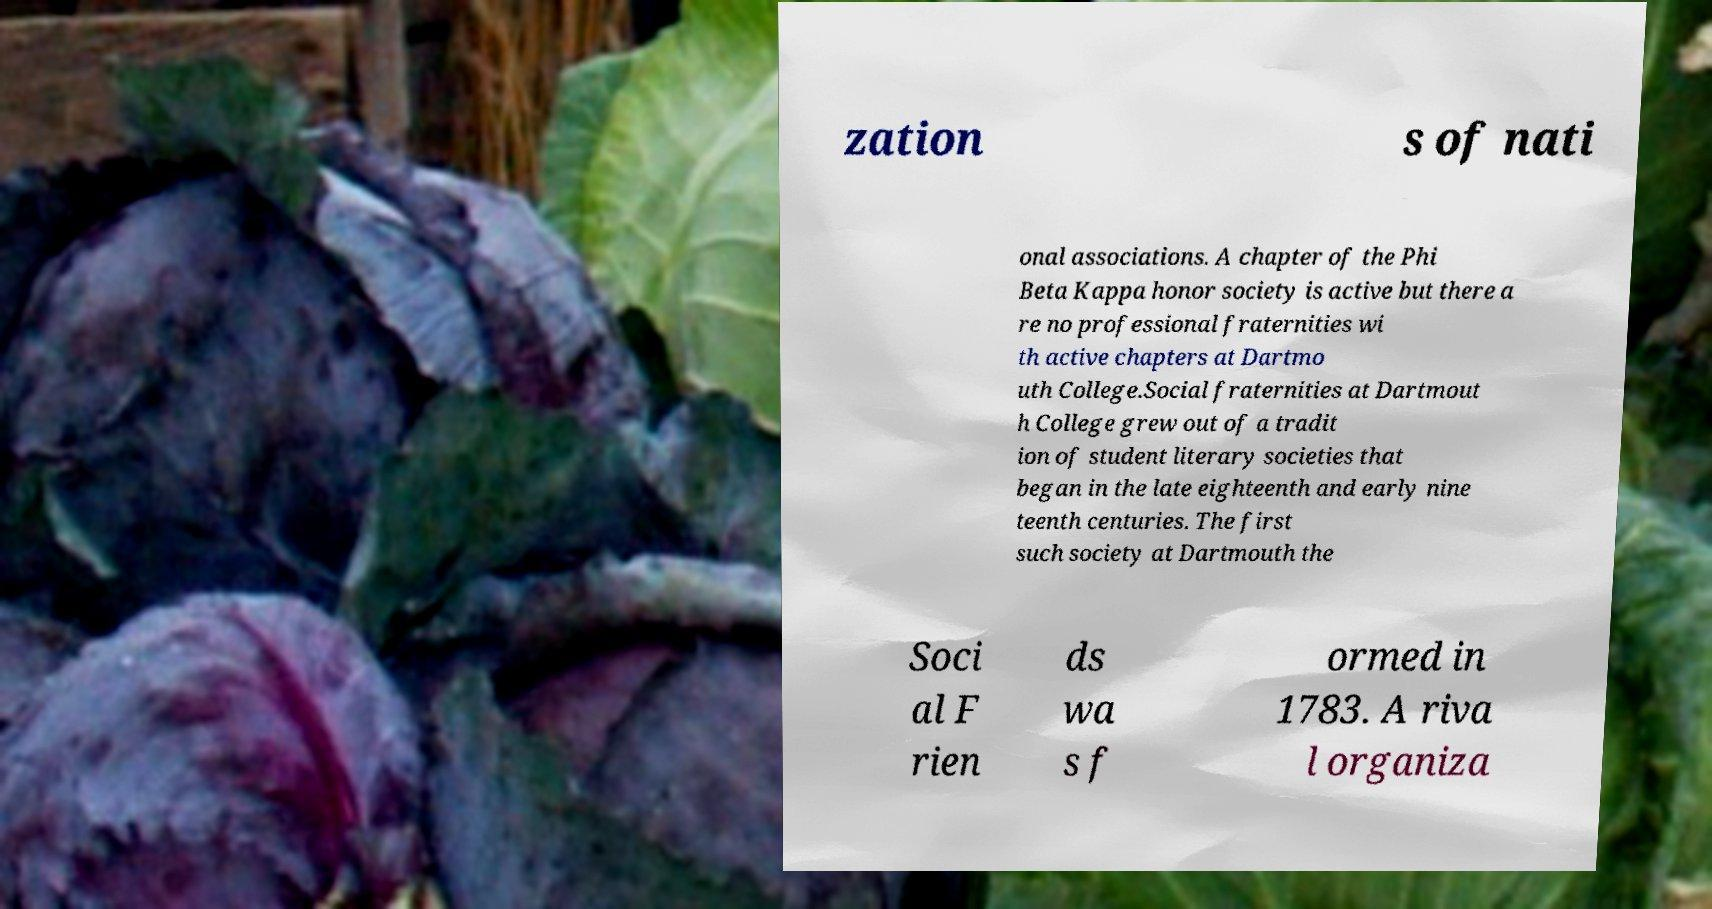Could you extract and type out the text from this image? zation s of nati onal associations. A chapter of the Phi Beta Kappa honor society is active but there a re no professional fraternities wi th active chapters at Dartmo uth College.Social fraternities at Dartmout h College grew out of a tradit ion of student literary societies that began in the late eighteenth and early nine teenth centuries. The first such society at Dartmouth the Soci al F rien ds wa s f ormed in 1783. A riva l organiza 